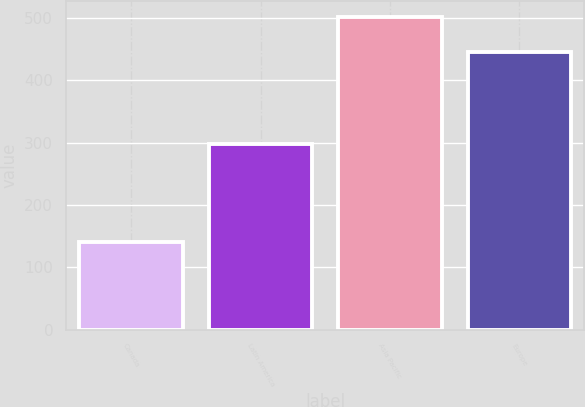Convert chart. <chart><loc_0><loc_0><loc_500><loc_500><bar_chart><fcel>Canada<fcel>Latin America<fcel>Asia Pacific<fcel>Europe<nl><fcel>140.3<fcel>297.1<fcel>502.1<fcel>446.2<nl></chart> 